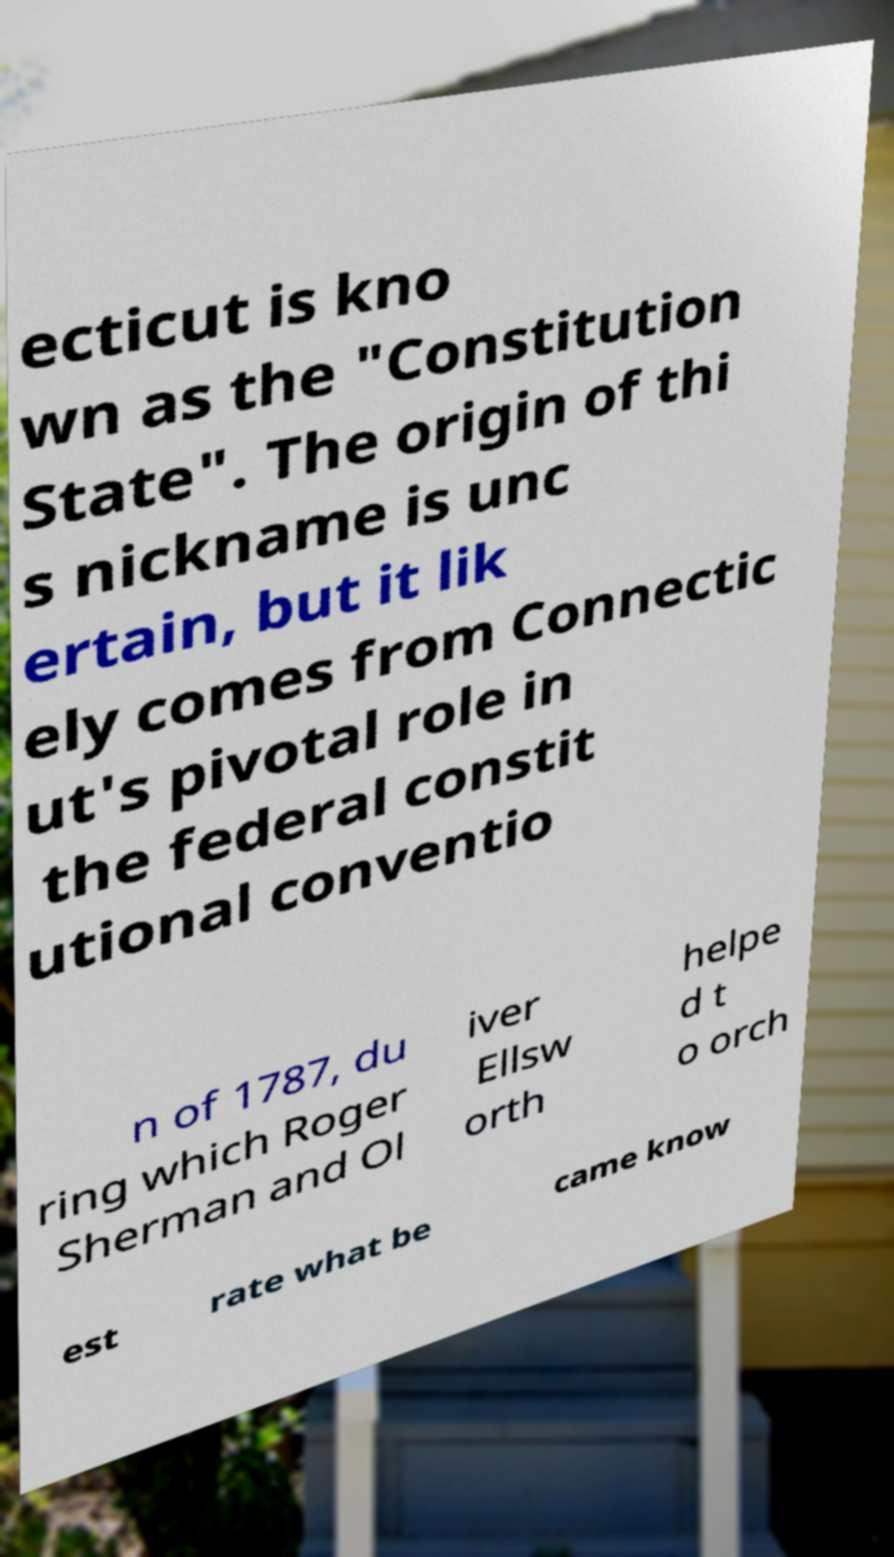There's text embedded in this image that I need extracted. Can you transcribe it verbatim? ecticut is kno wn as the "Constitution State". The origin of thi s nickname is unc ertain, but it lik ely comes from Connectic ut's pivotal role in the federal constit utional conventio n of 1787, du ring which Roger Sherman and Ol iver Ellsw orth helpe d t o orch est rate what be came know 